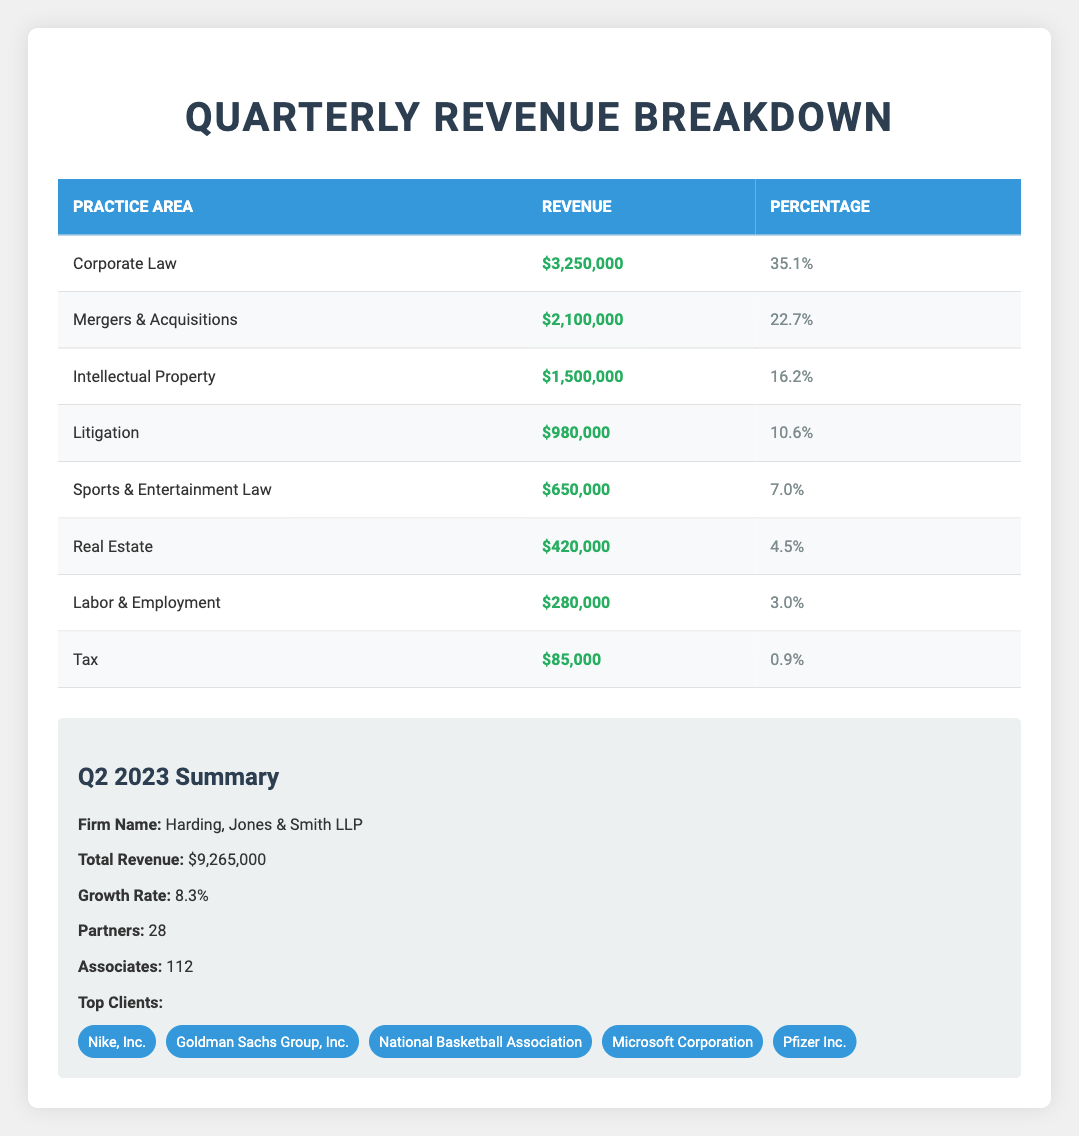What is the total revenue for the firm in Q2 2023? The total revenue is provided directly in the summary section of the table. It states that the total revenue for Harding, Jones & Smith LLP in Q2 2023 is $9,265,000.
Answer: $9,265,000 Which practice area generated the highest revenue? Looking at the revenue figures of each practice area in the table, Corporate Law has the highest revenue at $3,250,000.
Answer: Corporate Law What percentage of the total revenue did Labor & Employment generate? The percentage for Labor & Employment is shown in its respective row in the table. It indicates that Labor & Employment generated 3.0% of the total revenue.
Answer: 3.0% Calculate the combined revenue of the top three practice areas. Adding the revenues of the top three practice areas: Corporate Law ($3,250,000) + Mergers & Acquisitions ($2,100,000) + Intellectual Property ($1,500,000) results in a total of $6,850,000.
Answer: $6,850,000 Did Sports & Entertainment Law account for more than 5% of the total revenue? The percentage for Sports & Entertainment Law is 7.0%, which is greater than 5%. Therefore, yes, it did account for more than 5%.
Answer: Yes What is the total revenue generated by the two lowest-grossing practice areas combined? The two lowest-grossing practice areas are Tax ($85,000) and Labor & Employment ($280,000). Adding these together gives $85,000 + $280,000 = $365,000.
Answer: $365,000 How much more revenue did Mergers & Acquisitions generate compared to Litigation? The revenue for Mergers & Acquisitions is $2,100,000 and for Litigation is $980,000. The difference is $2,100,000 - $980,000 = $1,120,000.
Answer: $1,120,000 Is the growth rate higher than 10%? The growth rate is reported as 8.3%, which is less than 10%. Thus, the answer is no.
Answer: No What practice area follows Intellectual Property in terms of revenue generated? The table shows that after Intellectual Property, which has a revenue of $1,500,000, the next practice area is Litigation with a revenue of $980,000.
Answer: Litigation 